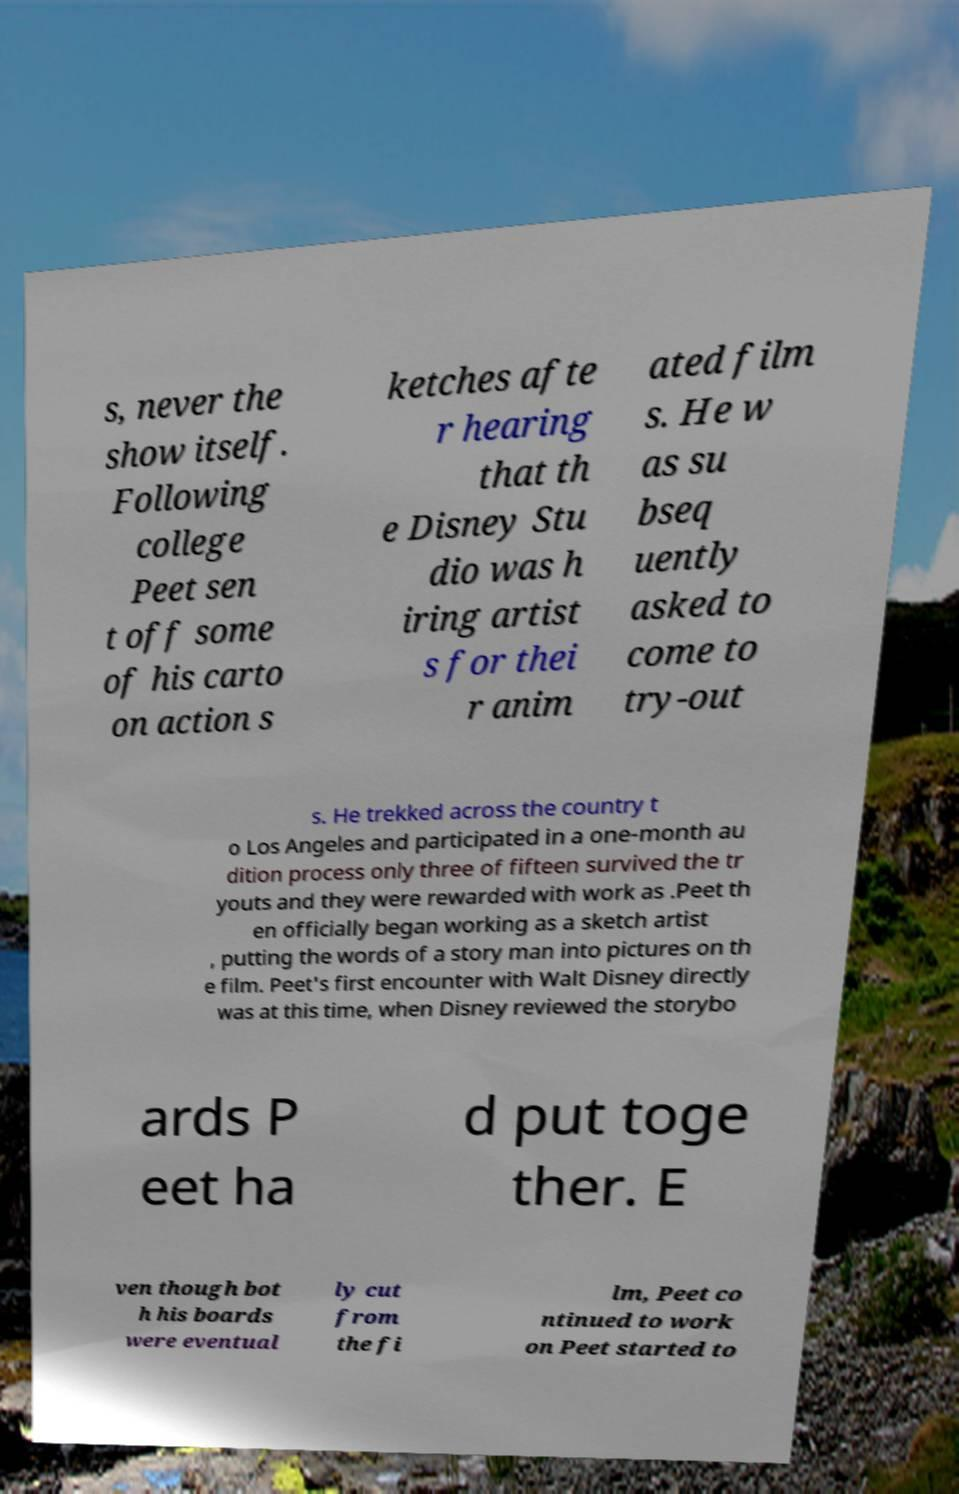Could you extract and type out the text from this image? s, never the show itself. Following college Peet sen t off some of his carto on action s ketches afte r hearing that th e Disney Stu dio was h iring artist s for thei r anim ated film s. He w as su bseq uently asked to come to try-out s. He trekked across the country t o Los Angeles and participated in a one-month au dition process only three of fifteen survived the tr youts and they were rewarded with work as .Peet th en officially began working as a sketch artist , putting the words of a story man into pictures on th e film. Peet's first encounter with Walt Disney directly was at this time, when Disney reviewed the storybo ards P eet ha d put toge ther. E ven though bot h his boards were eventual ly cut from the fi lm, Peet co ntinued to work on Peet started to 